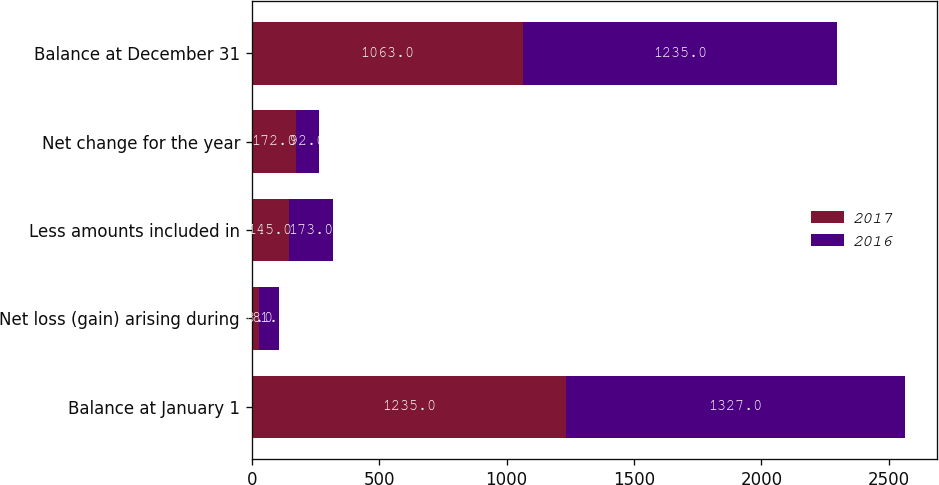Convert chart to OTSL. <chart><loc_0><loc_0><loc_500><loc_500><stacked_bar_chart><ecel><fcel>Balance at January 1<fcel>Net loss (gain) arising during<fcel>Less amounts included in<fcel>Net change for the year<fcel>Balance at December 31<nl><fcel>2017<fcel>1235<fcel>28<fcel>145<fcel>172<fcel>1063<nl><fcel>2016<fcel>1327<fcel>81<fcel>173<fcel>92<fcel>1235<nl></chart> 